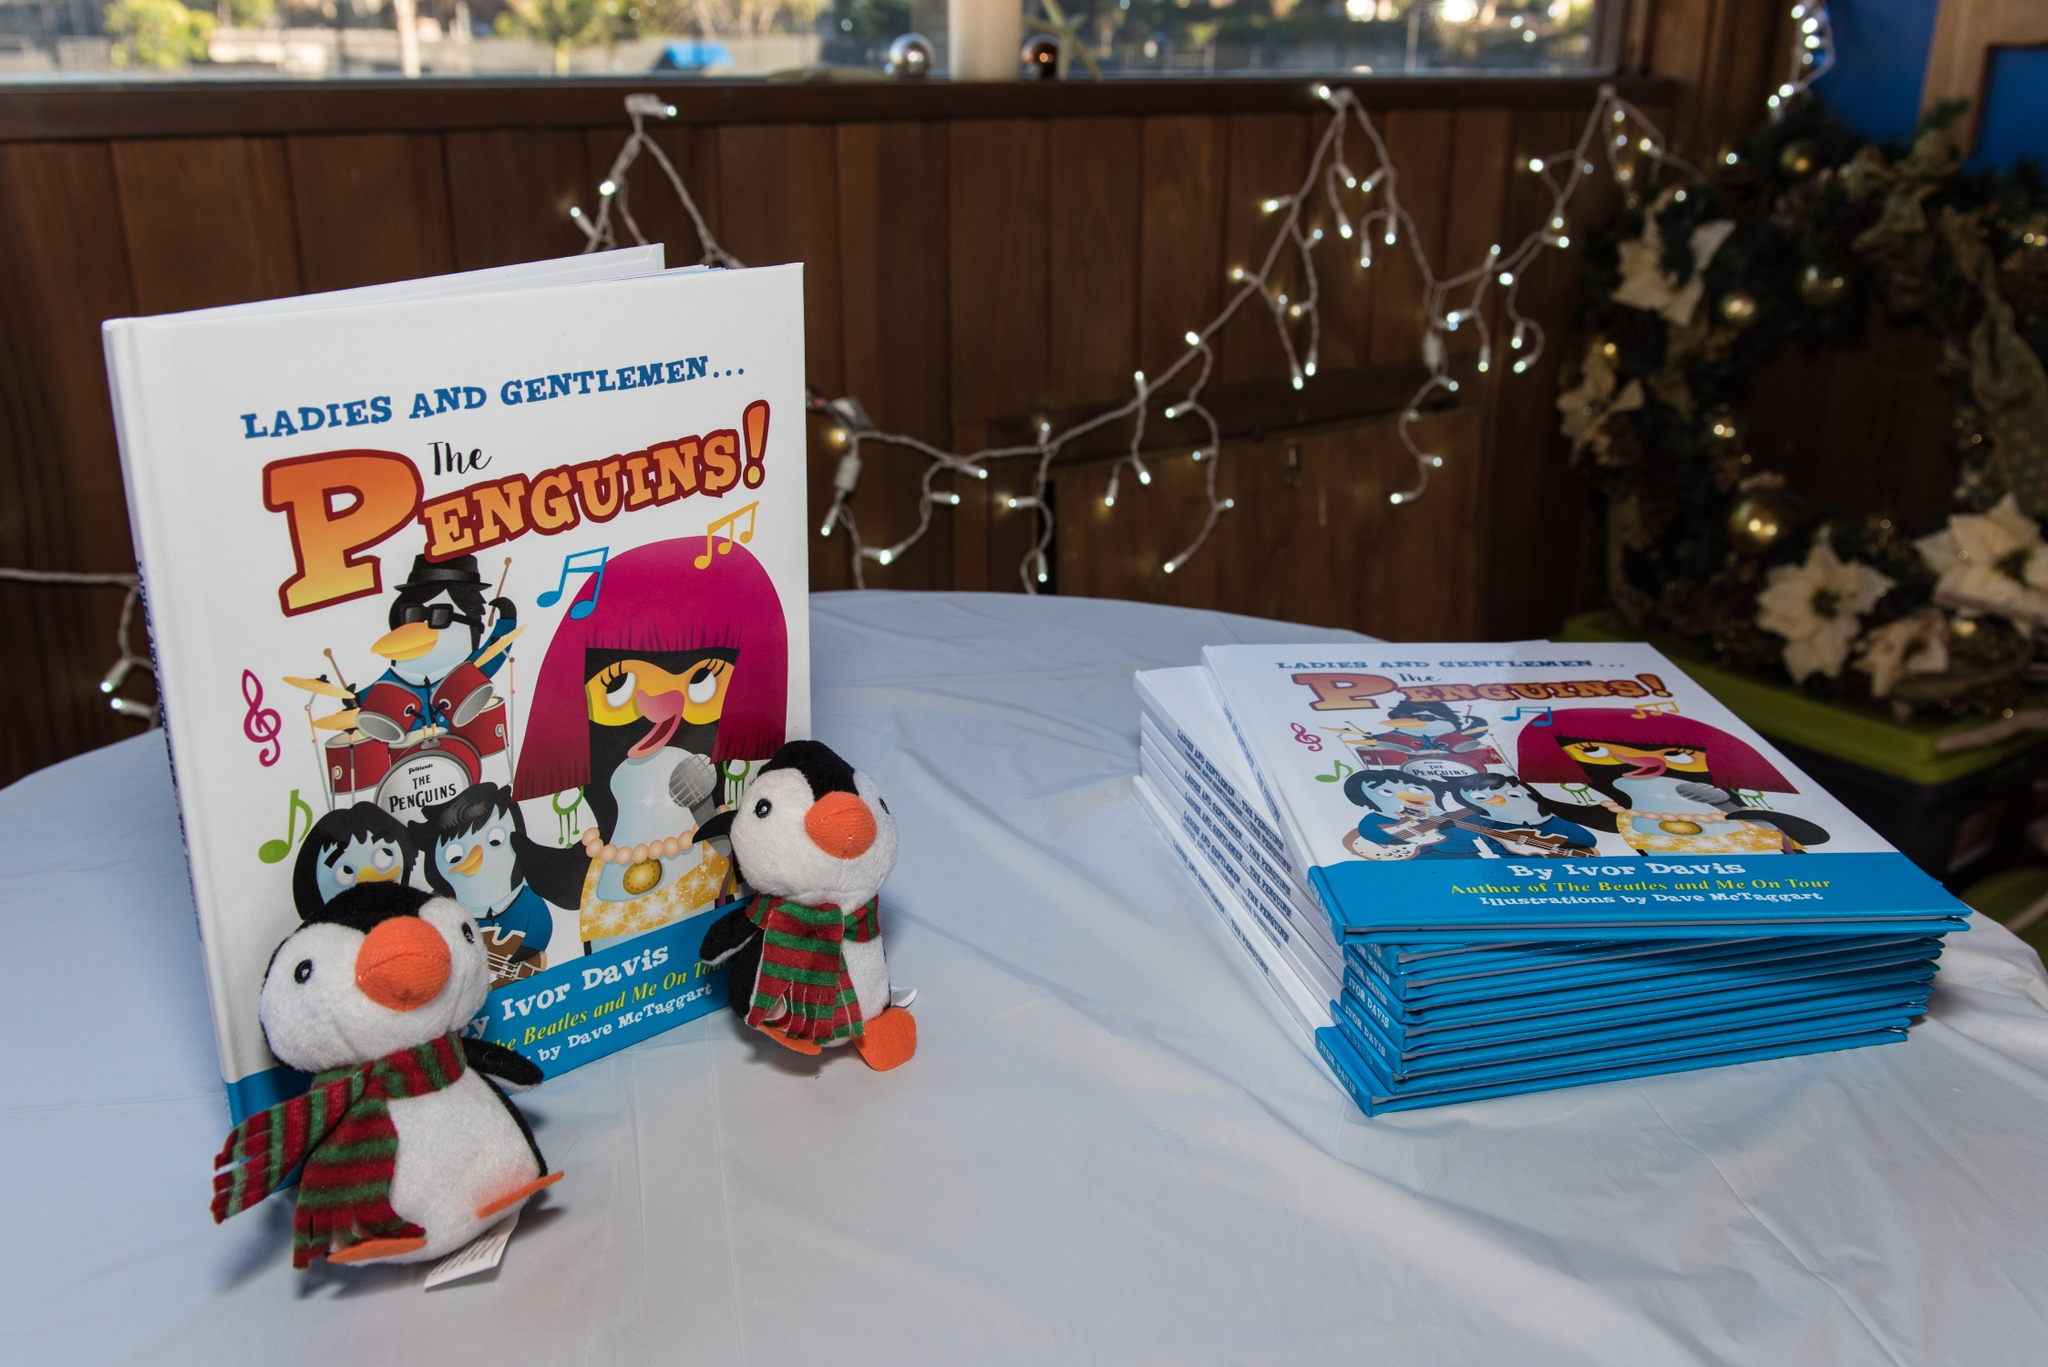Can you describe the main features of this image for me? Certainly! The image showcases a book signing event with the book titled 'Ladies and Gentlemen... The Penguins!' prominently displayed. The cover of the book features vibrant illustrations of penguin characters dressed as musicians, indicating a playful and entertaining theme. Accompanying the books on the table are two plush penguin toys, one wearing a green and red scarf and the other dressed in a holiday-themed outfit. The setting includes a white clothed table with the books arranged in stacks, and there are festive string lights in the background which suggest a holiday or celebratory occasion. 